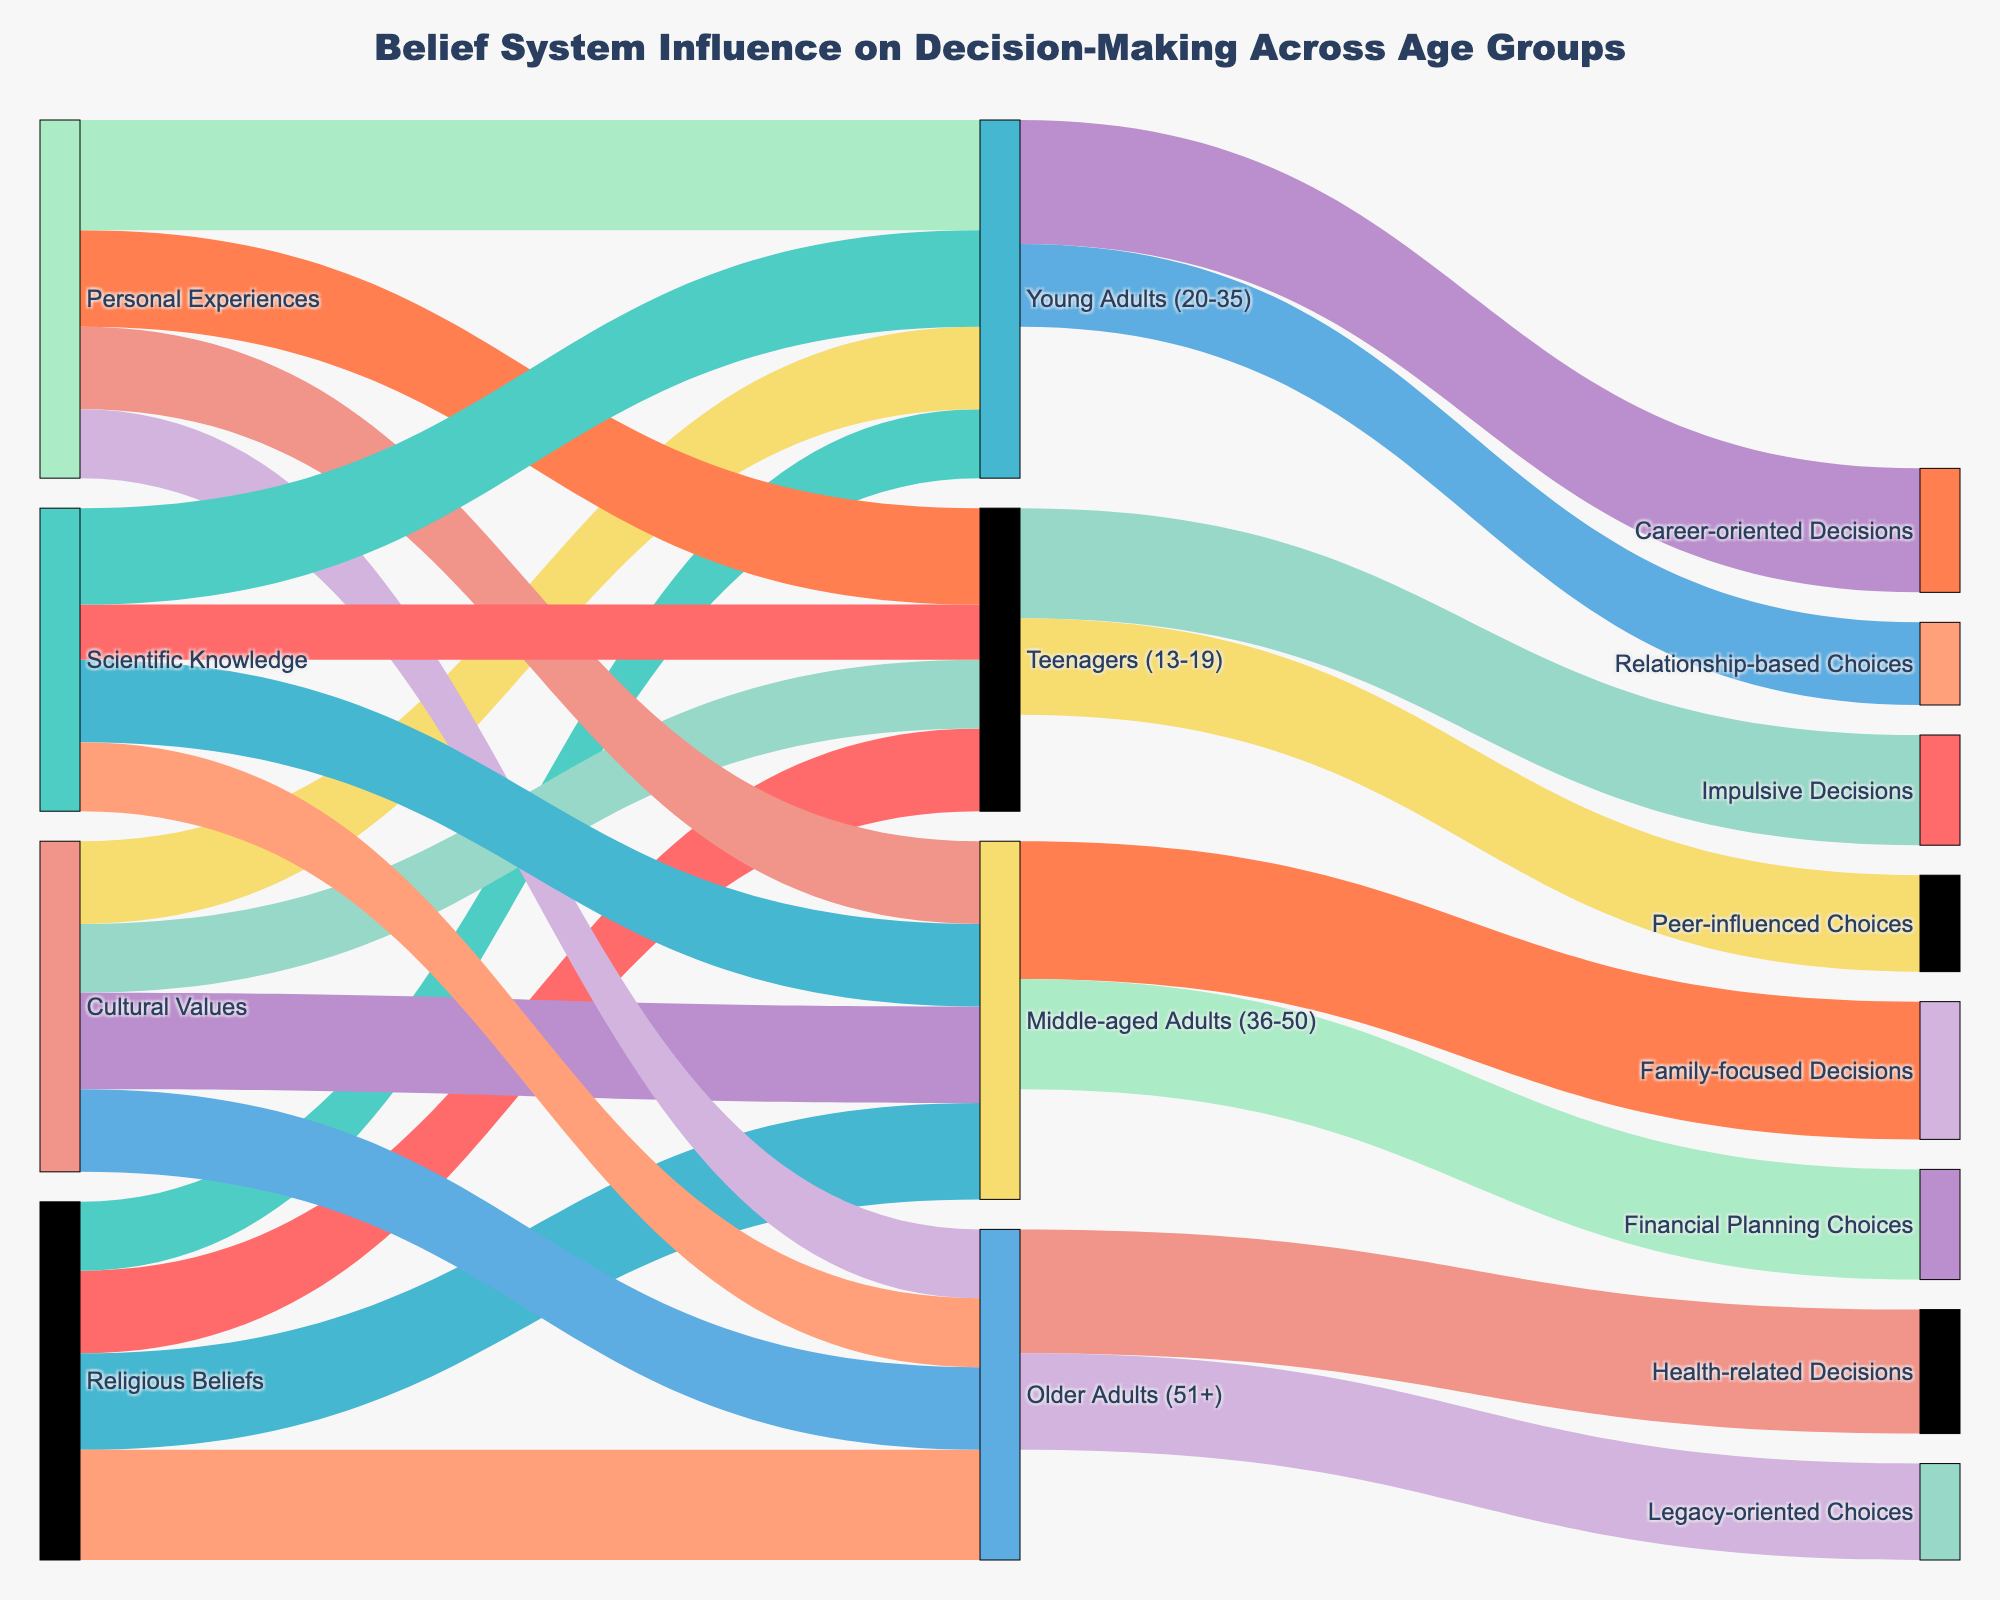What is the title of the Sankey diagram? The title of the Sankey diagram is displayed prominently at the top of the figure and reads "Belief System Influence on Decision-Making Across Age Groups."
Answer: Belief System Influence on Decision-Making Across Age Groups Which age group is most influenced by Religious Beliefs? To find this, look at the segments originating from "Religious Beliefs" and ending at different age groups. The segment with the highest value is the one ending at "Older Adults (51+)" with a value of 40.
Answer: Older Adults (51+) How many total decision points are influenced by Cultural Values across all age groups? Sum the "Value" columns of segments originating from "Cultural Values" and ending at all age groups: 25 (Teenagers) + 30 (Young Adults) + 35 (Middle-aged Adults) + 30 (Older Adults) = 120.
Answer: 120 What is the difference in influence between Personal Experiences on Young Adults and Older Adults? Look at the segments from "Personal Experiences" to "Young Adults" and "Older Adults." The values are 40 and 25, respectively. The difference is 40 - 25 = 15.
Answer: 15 Which belief system has the least influence on Teenagers (13-19)? Locate all segments ending at "Teenagers (13-19)" and compare their values. “Scientific Knowledge” has the smallest value of 20.
Answer: Scientific Knowledge Between Young Adults (20-35) and Middle-aged Adults (36-50), which age group makes more Career-oriented Decisions? Compare the values for segments ending at "Career-oriented Decisions" for both age groups. "Young Adults" have a value of 45, while "Middle-aged Adults" is not mapped to Career-oriented Decisions. Therefore, Young Adults have more.
Answer: Young Adults (20-35) What type of decisions are most influenced by Peer-influence among Teenagers? For Teenagers (13-19), compare the value of the segments leading to different decision outcomes. The segment "Peer-influenced Choices" has a value of 35.
Answer: Peer-influenced Choices Calculate the total influence of all belief systems on Middle-aged Adults (36-50). Sum the values for segments that lead to "Middle-aged Adults (36-50)": 35 (Religious Beliefs) + 35 (Cultural Values) + 30 (Personal Experiences) + 30 (Scientific Knowledge) = 130.
Answer: 130 Which decision outcomes are common to both Teenagers and Young Adults? Observe the segments ending at decision points from "Teenagers" and "Young Adults." Both have segments leading to "Impulsive Decisions," "Peer-influenced Choices," “Career-oriented Decisions,” and “Relationship-based Choices," but only "Relationship-based Choices" is common.
Answer: Relationship-based Choices 